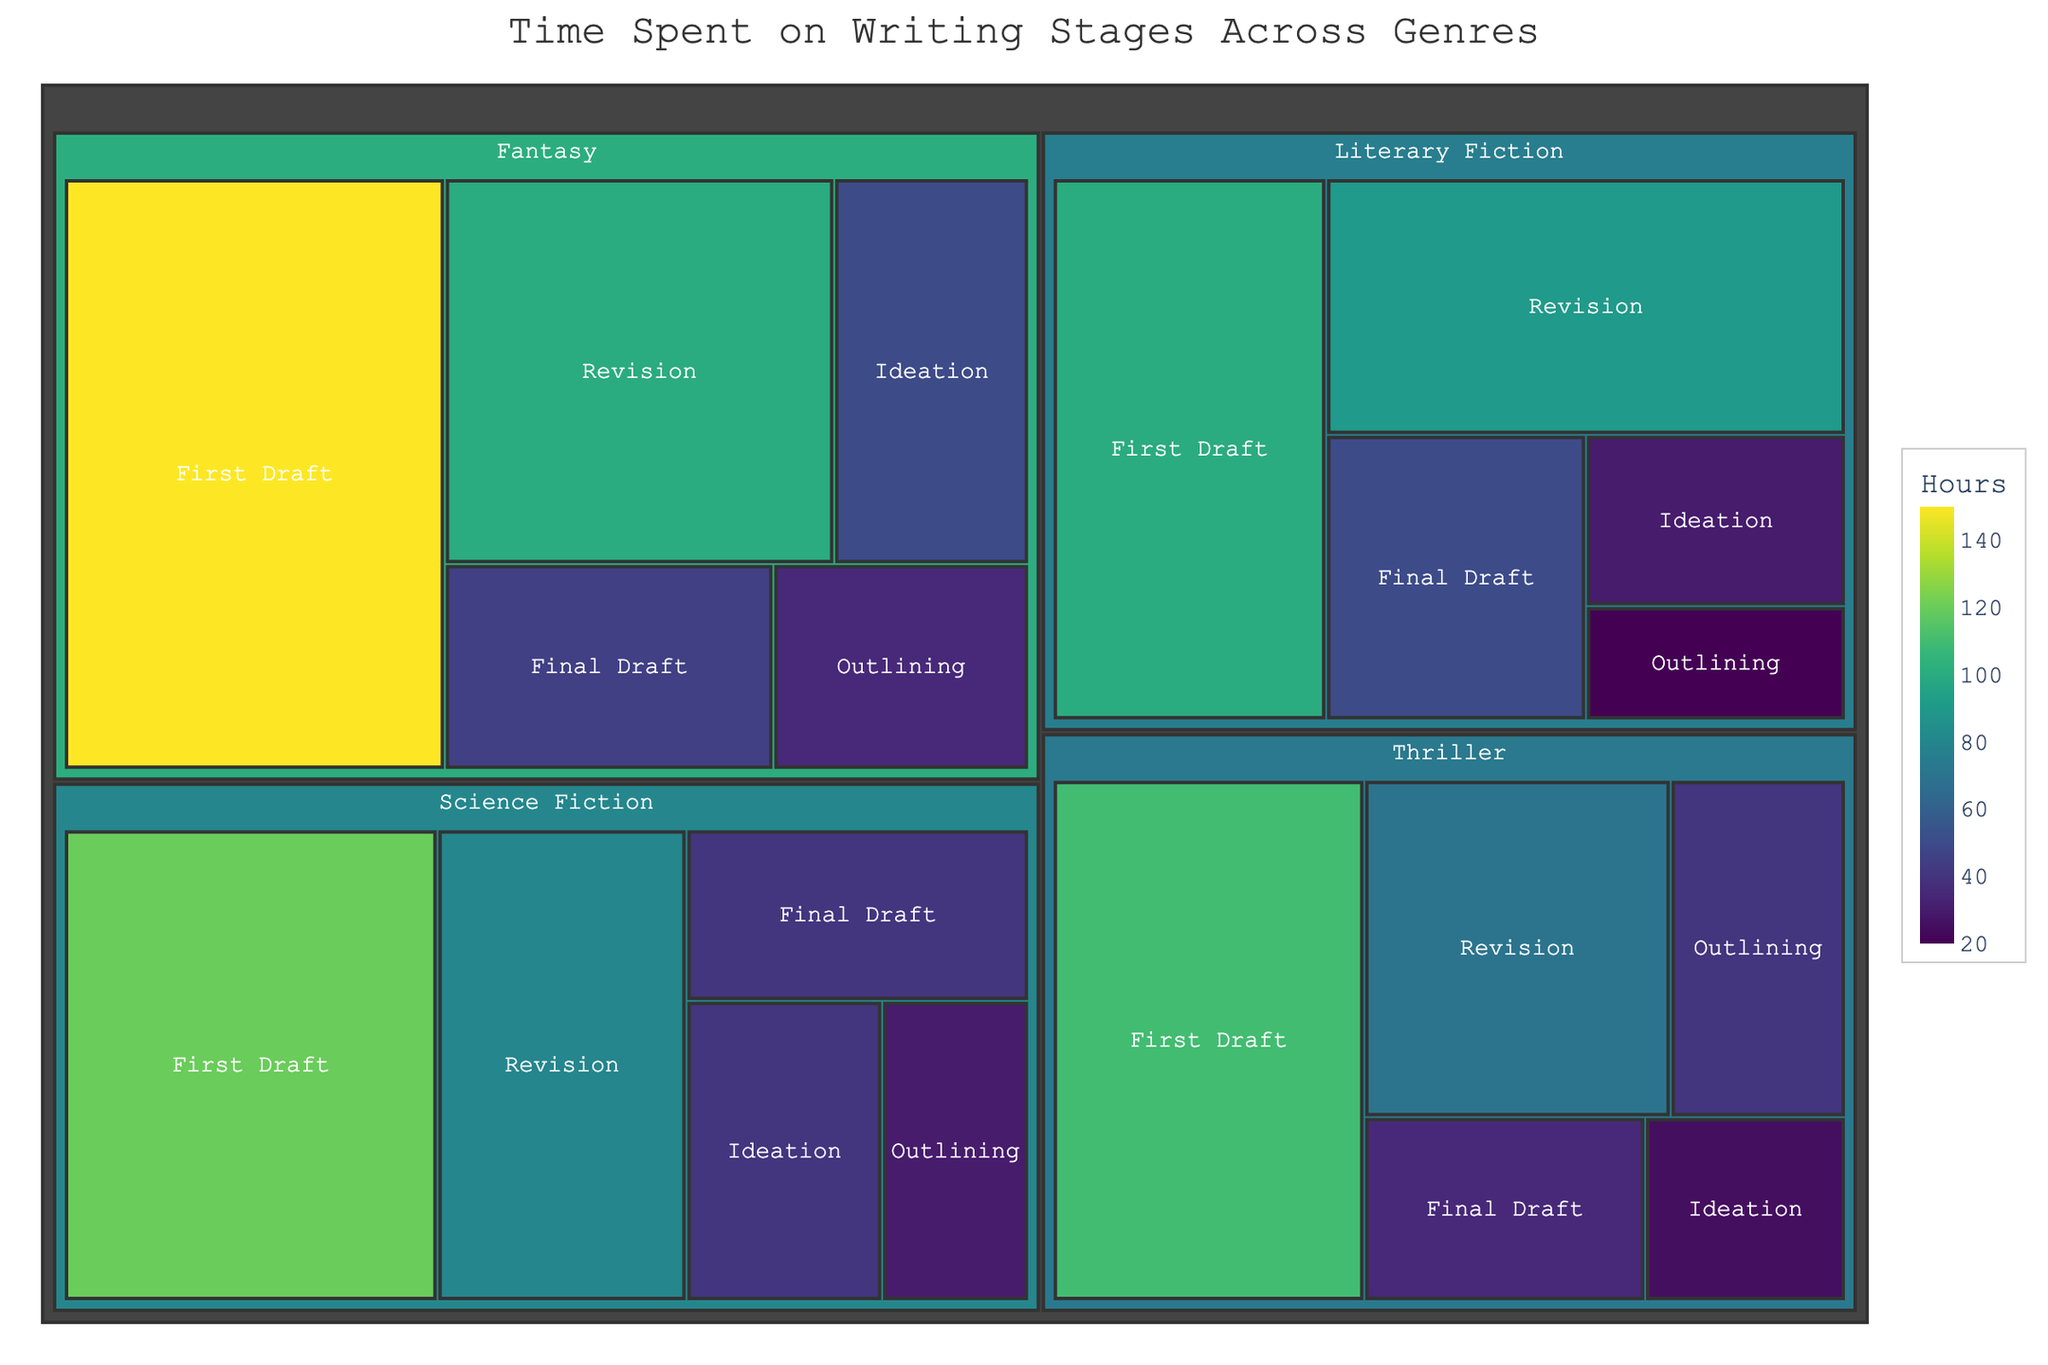What’s the total time spent on the Ideation stage across all genres? To get the total time, sum up the time spent on Ideation for all genres: Science Fiction (40 hours) + Fantasy (50 hours) + Literary Fiction (30 hours) + Thriller (25 hours). 40 + 50 + 30 + 25 = 145 hours.
Answer: 145 hours Which genre has the highest time spent on the First Draft stage? Look at the sizes of the First Draft stage blocks for each genre and find the largest: Science Fiction (120 hours), Fantasy (150 hours), Literary Fiction (100 hours), and Thriller (110 hours). Fantasy has the largest block.
Answer: Fantasy How much more time is spent on Revision in Literary Fiction compared to Thriller? Calculate the difference in time spent on Revision between Literary Fiction (90 hours) and Thriller (70 hours). 90 - 70 = 20 hours.
Answer: 20 hours What is the average time spent on the Final Draft stage across all genres? Sum the time spent on Final Draft for all genres: Science Fiction (40 hours), Fantasy (45 hours), Literary Fiction (50 hours), Thriller (35 hours). Then divide by the number of genres (4). (40+45+50+35) / 4 = 170 / 4 = 42.5 hours.
Answer: 42.5 hours In which genre is the time spent on Outlining the largest? Look at the sizes of the Outlining stage blocks for each genre and find the largest: Science Fiction (30 hours), Fantasy (35 hours), Literary Fiction (20 hours), Thriller (40 hours). Thriller has the largest block.
Answer: Thriller What’s the total time spent on all stages in Science Fiction? Sum up the time spent on all stages in Science Fiction: Ideation (40 hours) + Outlining (30 hours) + First Draft (120 hours) + Revision (80 hours) + Final Draft (40 hours). 40 + 30 + 120 + 80 + 40 = 310 hours.
Answer: 310 hours Compare the total time spent on the entire writing process between Fantasy and Thriller. Which one is greater? Sum the total time for all stages in both genres: Fantasy's total time = Ideation (50) + Outlining (35) + First Draft (150) + Revision (100) + Final Draft (45) = 380 hours. Thriller's total time = Ideation (25) + Outlining (40) + First Draft (110) + Revision (70) + Final Draft (35) = 280 hours. Fantasy's total is greater.
Answer: Fantasy Is the time spent on the Outlining stage in Literary Fiction less than the time spent on Ideation in Thriller? Compare the times directly from the figure: Outlining in Literary Fiction is 20 hours, while Ideation in Thriller is 25 hours. 20 < 25, so the time spent on the Outlining stage in Literary Fiction is less.
Answer: Yes 